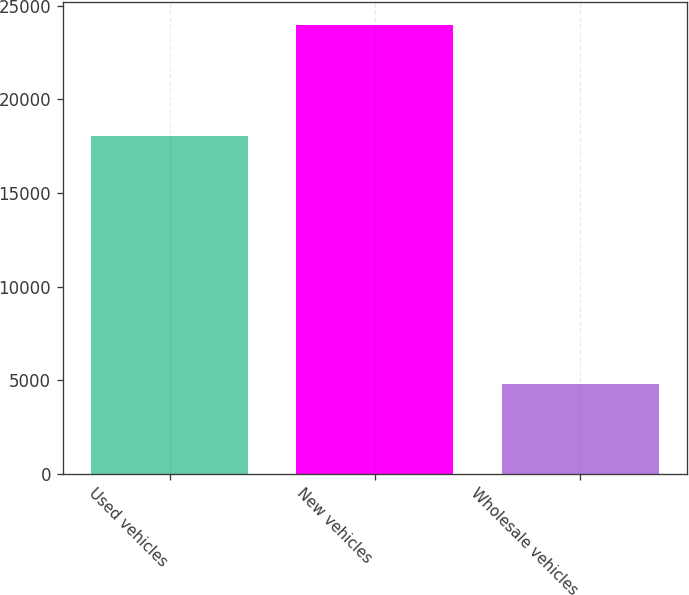Convert chart. <chart><loc_0><loc_0><loc_500><loc_500><bar_chart><fcel>Used vehicles<fcel>New vehicles<fcel>Wholesale vehicles<nl><fcel>18019<fcel>23989<fcel>4816<nl></chart> 